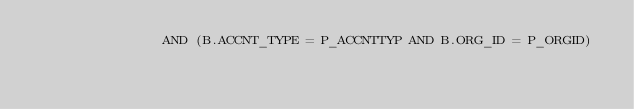<code> <loc_0><loc_0><loc_500><loc_500><_SQL_>                AND (B.ACCNT_TYPE = P_ACCNTTYP AND B.ORG_ID = P_ORGID)</code> 